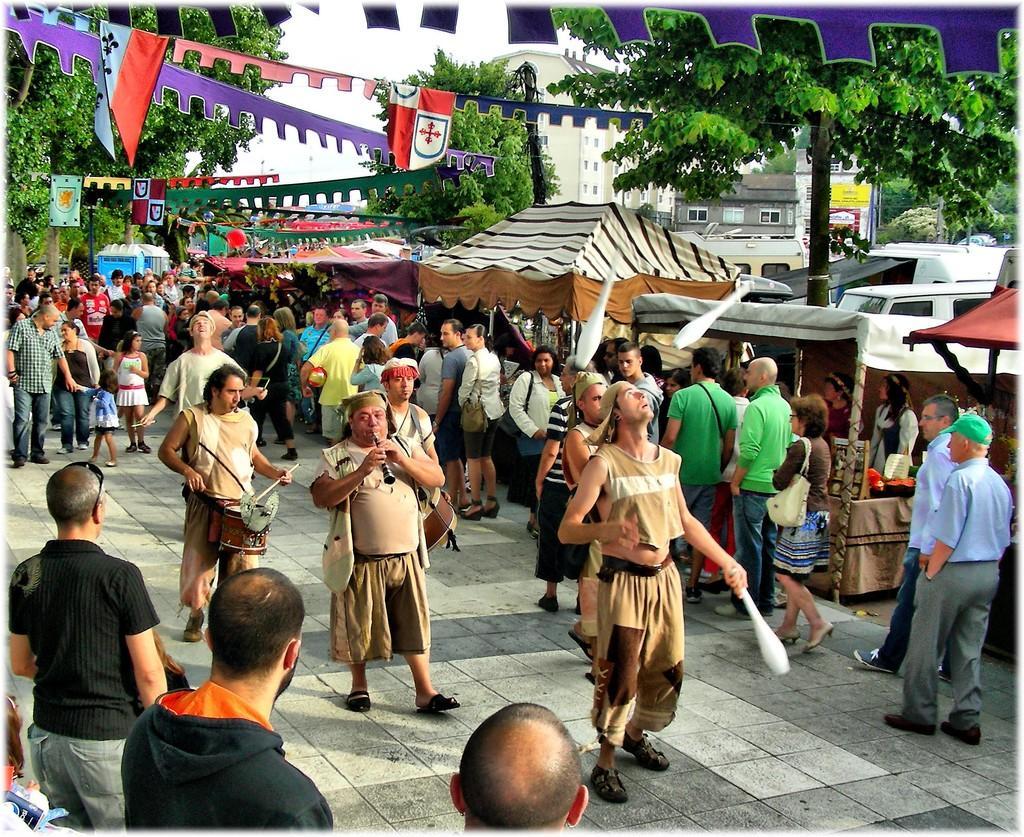In one or two sentences, can you explain what this image depicts? In this image there are many people standing on the path of a road. In this people there are few people are playing flutes and drums. On the right side of the image there are few stalls and trees. In the background there are some buildings and sky. 